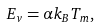Convert formula to latex. <formula><loc_0><loc_0><loc_500><loc_500>E _ { v } = \alpha k _ { B } T _ { m } ,</formula> 